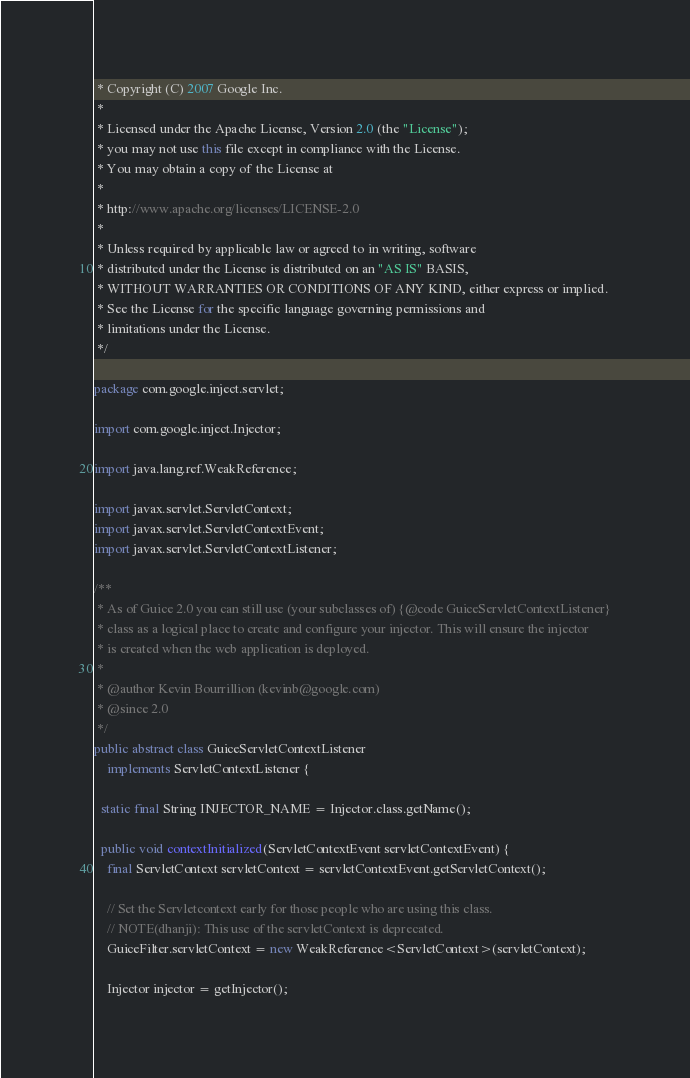<code> <loc_0><loc_0><loc_500><loc_500><_Java_> * Copyright (C) 2007 Google Inc.
 *
 * Licensed under the Apache License, Version 2.0 (the "License");
 * you may not use this file except in compliance with the License.
 * You may obtain a copy of the License at
 *
 * http://www.apache.org/licenses/LICENSE-2.0
 *
 * Unless required by applicable law or agreed to in writing, software
 * distributed under the License is distributed on an "AS IS" BASIS,
 * WITHOUT WARRANTIES OR CONDITIONS OF ANY KIND, either express or implied.
 * See the License for the specific language governing permissions and
 * limitations under the License.
 */

package com.google.inject.servlet;

import com.google.inject.Injector;

import java.lang.ref.WeakReference;

import javax.servlet.ServletContext;
import javax.servlet.ServletContextEvent;
import javax.servlet.ServletContextListener;

/**
 * As of Guice 2.0 you can still use (your subclasses of) {@code GuiceServletContextListener}
 * class as a logical place to create and configure your injector. This will ensure the injector
 * is created when the web application is deployed.
 * 
 * @author Kevin Bourrillion (kevinb@google.com)
 * @since 2.0
 */
public abstract class GuiceServletContextListener
    implements ServletContextListener {

  static final String INJECTOR_NAME = Injector.class.getName();

  public void contextInitialized(ServletContextEvent servletContextEvent) {
    final ServletContext servletContext = servletContextEvent.getServletContext();

    // Set the Servletcontext early for those people who are using this class.
    // NOTE(dhanji): This use of the servletContext is deprecated.
    GuiceFilter.servletContext = new WeakReference<ServletContext>(servletContext);

    Injector injector = getInjector();</code> 